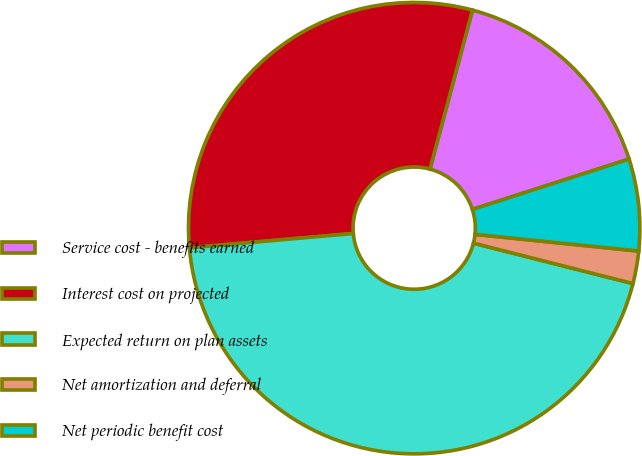Convert chart to OTSL. <chart><loc_0><loc_0><loc_500><loc_500><pie_chart><fcel>Service cost - benefits earned<fcel>Interest cost on projected<fcel>Expected return on plan assets<fcel>Net amortization and deferral<fcel>Net periodic benefit cost<nl><fcel>15.89%<fcel>30.55%<fcel>44.66%<fcel>2.33%<fcel>6.57%<nl></chart> 